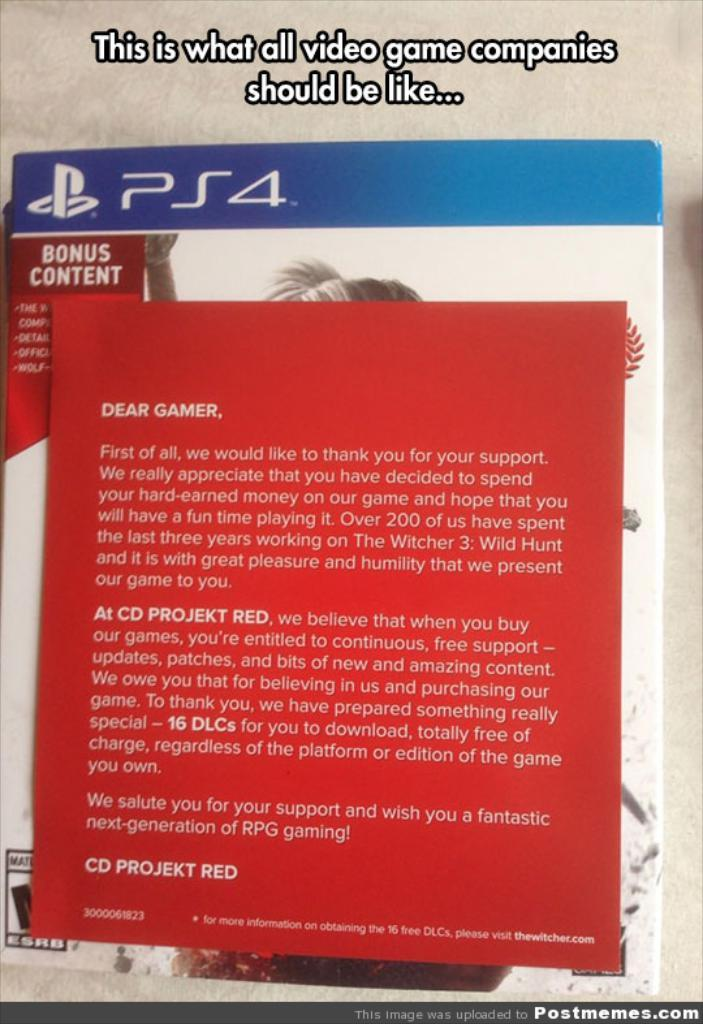<image>
Summarize the visual content of the image. A playstation 4 game comes with a thank you note from the manufacturer in it. 